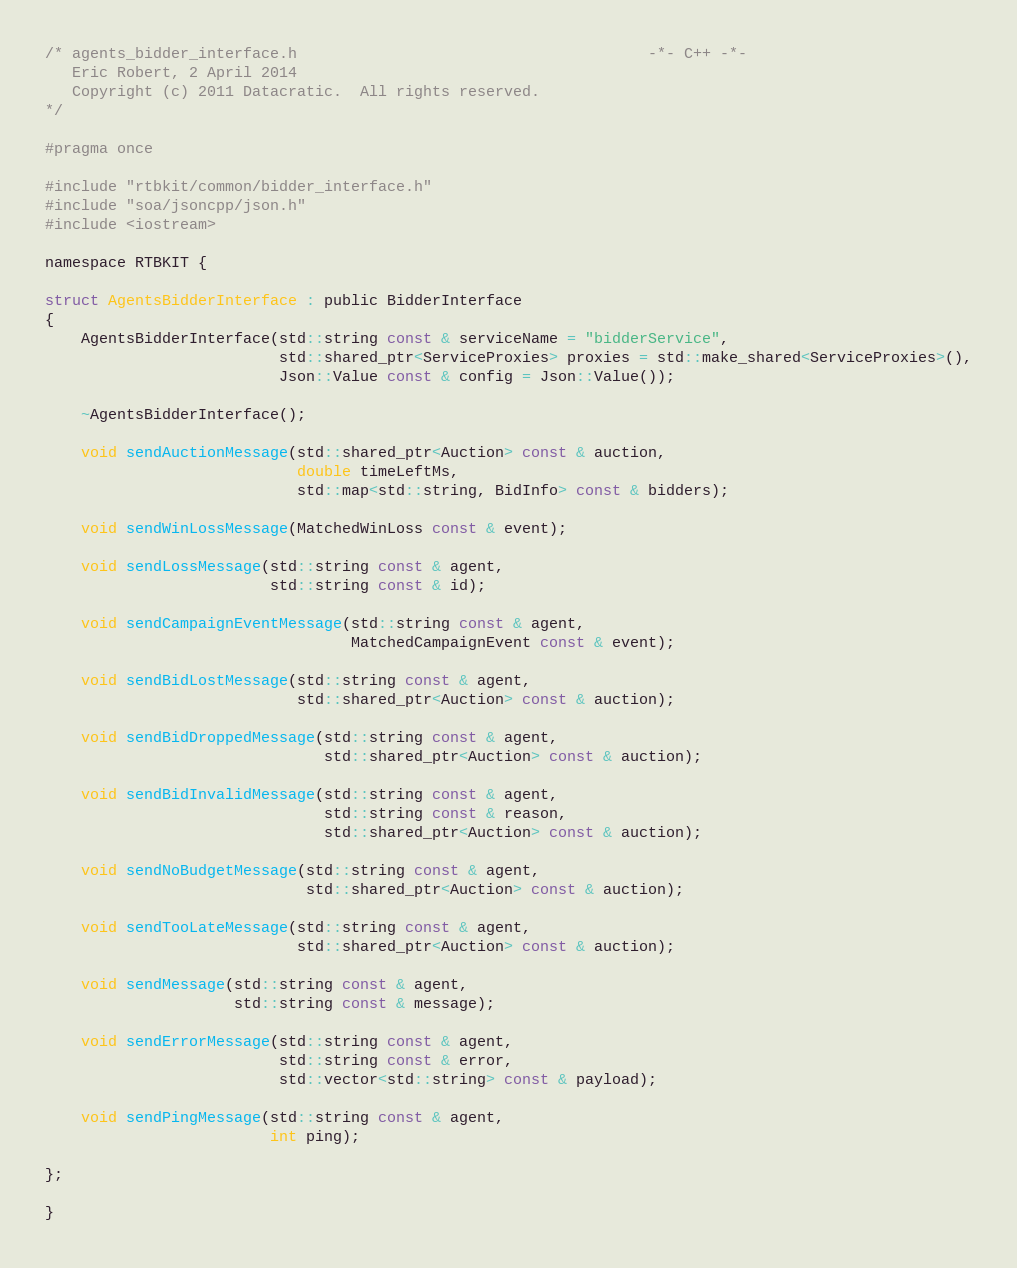Convert code to text. <code><loc_0><loc_0><loc_500><loc_500><_C_>/* agents_bidder_interface.h                                       -*- C++ -*-
   Eric Robert, 2 April 2014
   Copyright (c) 2011 Datacratic.  All rights reserved.
*/

#pragma once

#include "rtbkit/common/bidder_interface.h"
#include "soa/jsoncpp/json.h"
#include <iostream>

namespace RTBKIT {

struct AgentsBidderInterface : public BidderInterface
{
    AgentsBidderInterface(std::string const & serviceName = "bidderService",
                          std::shared_ptr<ServiceProxies> proxies = std::make_shared<ServiceProxies>(),
                          Json::Value const & config = Json::Value());

    ~AgentsBidderInterface();

    void sendAuctionMessage(std::shared_ptr<Auction> const & auction,
                            double timeLeftMs,
                            std::map<std::string, BidInfo> const & bidders);

    void sendWinLossMessage(MatchedWinLoss const & event);

    void sendLossMessage(std::string const & agent,
                         std::string const & id);

    void sendCampaignEventMessage(std::string const & agent,
                                  MatchedCampaignEvent const & event);

    void sendBidLostMessage(std::string const & agent,
                            std::shared_ptr<Auction> const & auction);

    void sendBidDroppedMessage(std::string const & agent,
                               std::shared_ptr<Auction> const & auction);

    void sendBidInvalidMessage(std::string const & agent,
                               std::string const & reason,
                               std::shared_ptr<Auction> const & auction);

    void sendNoBudgetMessage(std::string const & agent,
                             std::shared_ptr<Auction> const & auction);

    void sendTooLateMessage(std::string const & agent,
                            std::shared_ptr<Auction> const & auction);

    void sendMessage(std::string const & agent,
                     std::string const & message);

    void sendErrorMessage(std::string const & agent,
                          std::string const & error,
                          std::vector<std::string> const & payload);

    void sendPingMessage(std::string const & agent,
                         int ping);

};

}

</code> 